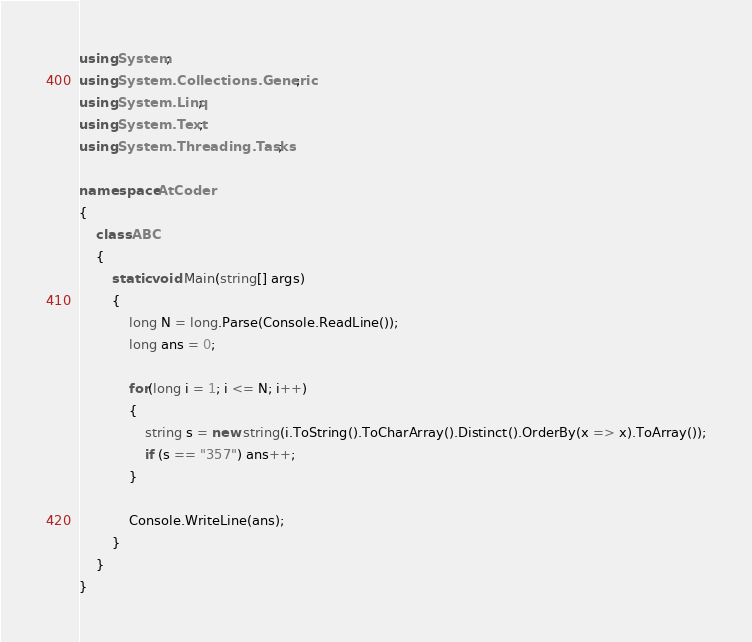Convert code to text. <code><loc_0><loc_0><loc_500><loc_500><_C#_>using System;
using System.Collections.Generic;
using System.Linq;
using System.Text;
using System.Threading.Tasks;

namespace AtCoder
{
    class ABC
    {
        static void Main(string[] args)
        {
            long N = long.Parse(Console.ReadLine());
            long ans = 0;

            for(long i = 1; i <= N; i++)
            {
                string s = new string(i.ToString().ToCharArray().Distinct().OrderBy(x => x).ToArray());
                if (s == "357") ans++;
            }

            Console.WriteLine(ans);
        }
    }
}
</code> 